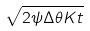Convert formula to latex. <formula><loc_0><loc_0><loc_500><loc_500>\sqrt { 2 \psi \Delta \theta K t }</formula> 